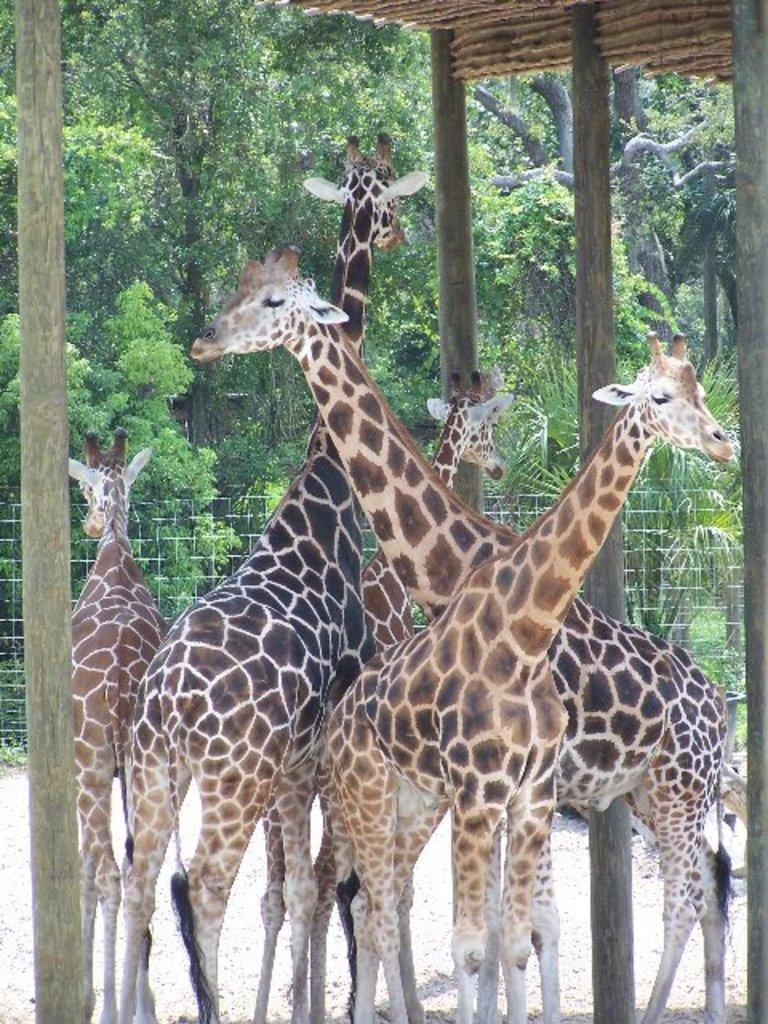What animals are in the foreground of the image? There are giraffes in the foreground of the image. Where are the giraffes located in relation to a shelter? The giraffes are under a shelter. What can be seen in the background of the image? There are trees and fencing in the background of the image. What type of party is being held under the shelter in the image? There is no party present in the image; it features giraffes under a shelter with trees and fencing in the background. 